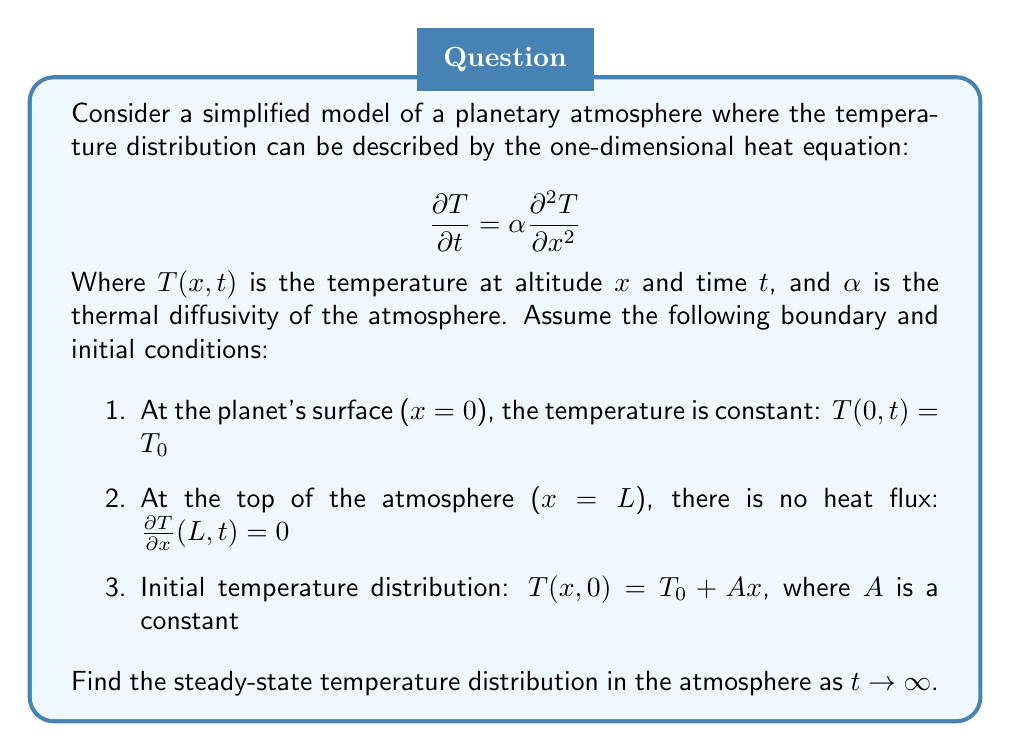Solve this math problem. To solve this problem, we'll follow these steps:

1) First, we need to recognize that the steady-state solution is independent of time. This means we're looking for a solution where $\frac{\partial T}{\partial t} = 0$.

2) With this condition, our heat equation reduces to:

   $$0 = \alpha \frac{d^2 T}{dx^2}$$

3) Integrating this twice with respect to x:

   $$T(x) = C_1x + C_2$$

   where $C_1$ and $C_2$ are constants we need to determine using the boundary conditions.

4) Apply the first boundary condition: $T(0) = T_0$
   This gives us: $T_0 = C_2$

5) Apply the second boundary condition: $\frac{dT}{dx}(L) = 0$
   Taking the derivative of our general solution: $\frac{dT}{dx} = C_1$
   Setting this to zero at x = L: $C_1 = 0$

6) Therefore, our steady-state solution is:

   $$T(x) = T_0$$

This result shows that in the steady-state, the temperature throughout the atmosphere becomes uniform and equal to the surface temperature. This makes sense from a physical standpoint: without any external heat sources or sinks, and given enough time, heat will distribute evenly throughout the system due to diffusion.

Note: The initial condition $T(x,0) = T_0 + Ax$ doesn't affect the steady-state solution. It only influences how the system evolves towards the steady-state.
Answer: The steady-state temperature distribution in the atmosphere is:

$$T(x) = T_0$$

Where $T_0$ is the constant temperature at the planet's surface. 